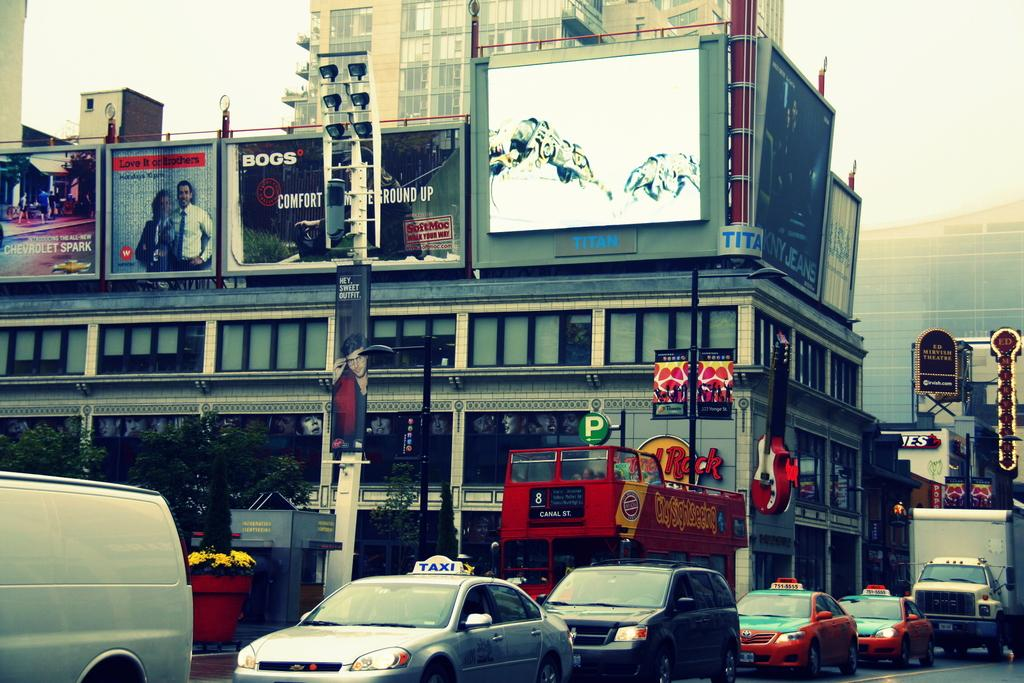<image>
Write a terse but informative summary of the picture. A city street scene has a taxi and a double-decker bus. 